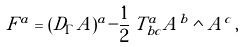<formula> <loc_0><loc_0><loc_500><loc_500>F ^ { a } = ( D _ { \Gamma } A ) ^ { a } - \frac { 1 } { 2 } \, T _ { b c } ^ { a } A ^ { b } \wedge A ^ { c } \, ,</formula> 